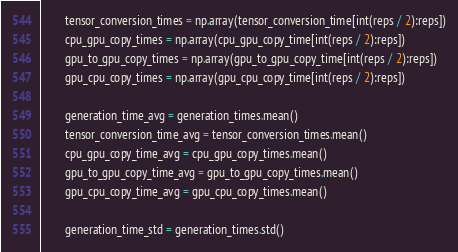<code> <loc_0><loc_0><loc_500><loc_500><_Python_>        tensor_conversion_times = np.array(tensor_conversion_time[int(reps / 2):reps])
        cpu_gpu_copy_times = np.array(cpu_gpu_copy_time[int(reps / 2):reps])
        gpu_to_gpu_copy_times = np.array(gpu_to_gpu_copy_time[int(reps / 2):reps])
        gpu_cpu_copy_times = np.array(gpu_cpu_copy_time[int(reps / 2):reps])

        generation_time_avg = generation_times.mean()
        tensor_conversion_time_avg = tensor_conversion_times.mean()
        cpu_gpu_copy_time_avg = cpu_gpu_copy_times.mean()
        gpu_to_gpu_copy_time_avg = gpu_to_gpu_copy_times.mean()
        gpu_cpu_copy_time_avg = gpu_cpu_copy_times.mean()

        generation_time_std = generation_times.std()</code> 